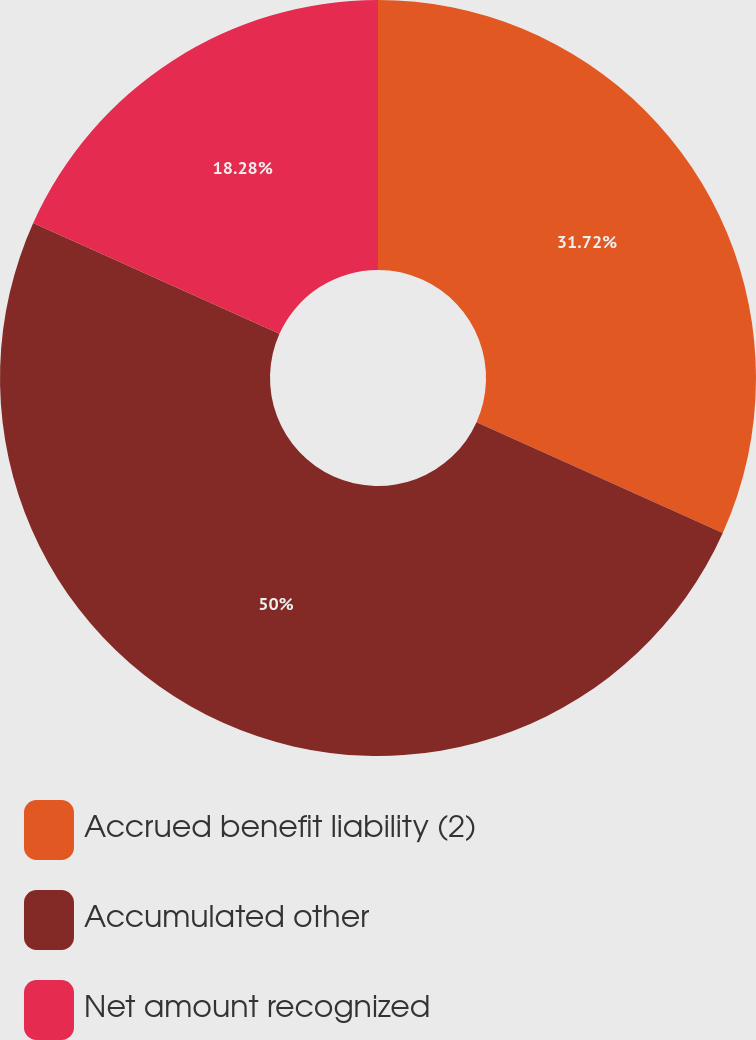Convert chart to OTSL. <chart><loc_0><loc_0><loc_500><loc_500><pie_chart><fcel>Accrued benefit liability (2)<fcel>Accumulated other<fcel>Net amount recognized<nl><fcel>31.72%<fcel>50.0%<fcel>18.28%<nl></chart> 